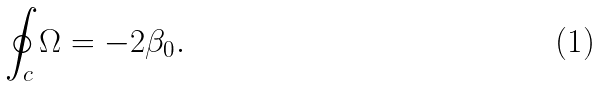<formula> <loc_0><loc_0><loc_500><loc_500>\oint _ { c } \Omega = - 2 \beta _ { 0 } .</formula> 